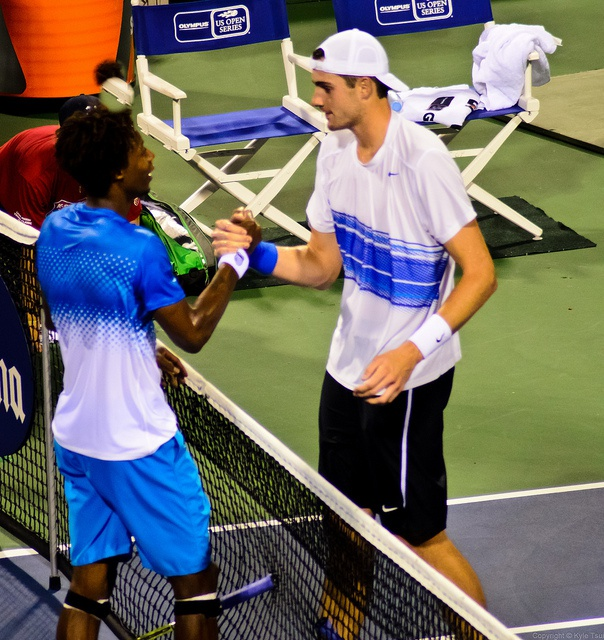Describe the objects in this image and their specific colors. I can see people in maroon, lightgray, black, orange, and olive tones, people in maroon, blue, black, lavender, and darkblue tones, chair in maroon, navy, olive, and beige tones, chair in maroon, navy, beige, and darkgray tones, and people in maroon, black, and red tones in this image. 